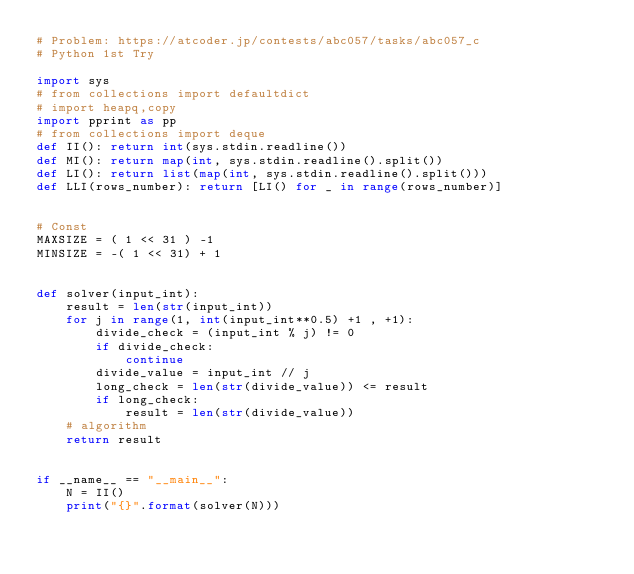Convert code to text. <code><loc_0><loc_0><loc_500><loc_500><_Python_># Problem: https://atcoder.jp/contests/abc057/tasks/abc057_c
# Python 1st Try

import sys
# from collections import defaultdict
# import heapq,copy
import pprint as pp
# from collections import deque
def II(): return int(sys.stdin.readline())
def MI(): return map(int, sys.stdin.readline().split())
def LI(): return list(map(int, sys.stdin.readline().split()))
def LLI(rows_number): return [LI() for _ in range(rows_number)]


# Const
MAXSIZE = ( 1 << 31 ) -1
MINSIZE = -( 1 << 31) + 1


def solver(input_int):
    result = len(str(input_int))
    for j in range(1, int(input_int**0.5) +1 , +1):
        divide_check = (input_int % j) != 0
        if divide_check:
            continue
        divide_value = input_int // j
        long_check = len(str(divide_value)) <= result
        if long_check:
            result = len(str(divide_value))
    # algorithm
    return result


if __name__ == "__main__":
    N = II()
    print("{}".format(solver(N)))
</code> 